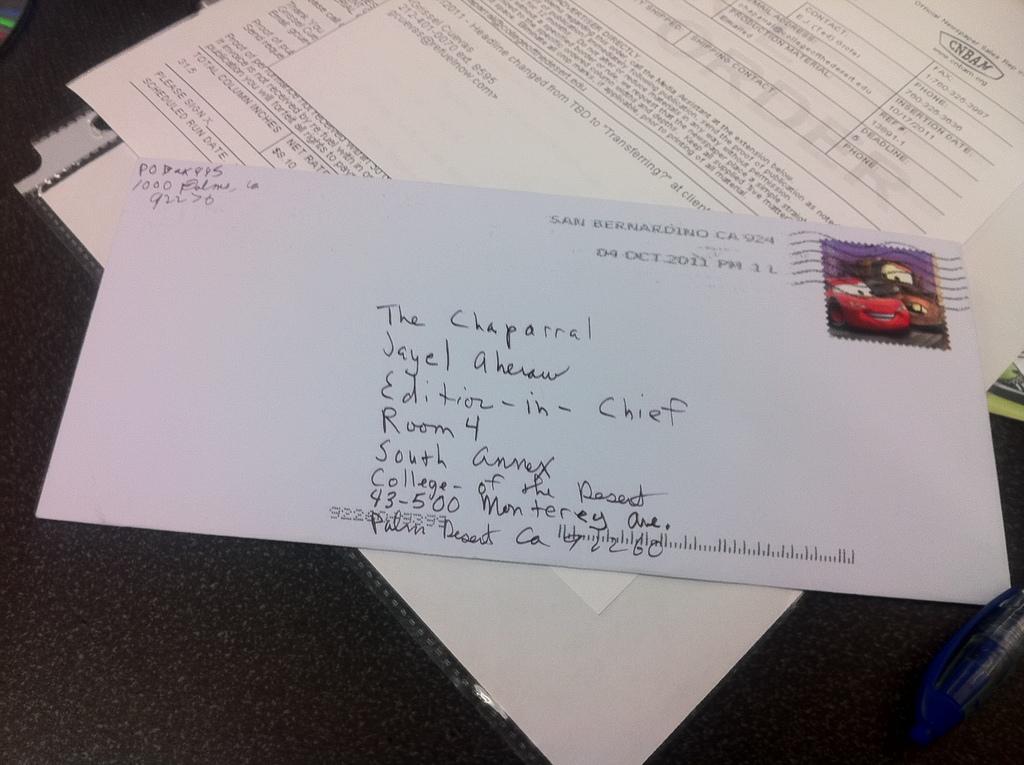Where is the letter posted to?
Your response must be concise. Palm desert ca. Who is the letter addressed to?
Ensure brevity in your answer.  The chaparrel. 